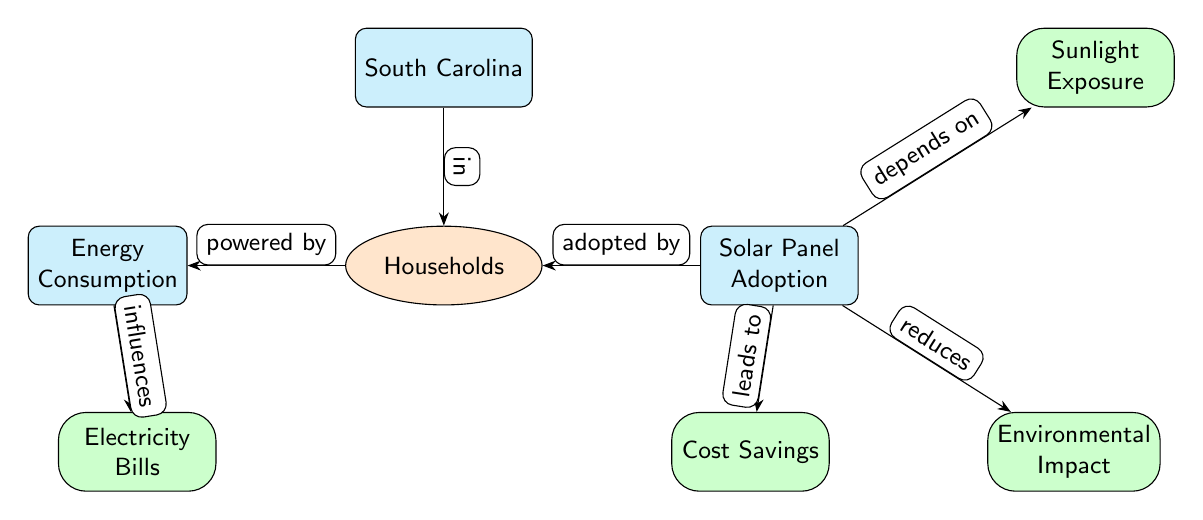What is the main topic of the diagram? The primary focus of the diagram is on the relationship between energy consumption and solar panel adoption within South Carolina households, indicated by the main nodes.
Answer: Energy Consumption and Solar Panel Adoption How many main nodes are in the diagram? Counting the nodes classified under the main category, there are three main nodes: South Carolina, Energy Consumption, and Solar Panel Adoption.
Answer: 3 Which node is influenced by energy consumption? The Electricity Bills node is directly indicated to be influenced by the Energy Consumption node, as shown by the edge labeled "influences."
Answer: Electricity Bills What does solar panel adoption lead to? According to the diagram, Solar Panel Adoption leads to Cost Savings, showing its impact on financial aspects for households.
Answer: Cost Savings How is solar panel adoption related to sunlight exposure? The diagram specifies that Solar Panel Adoption "depends on" Sunlight Exposure, indicating a necessary relationship between the two.
Answer: Depends on What are the three impacts of solar panel adoption? The diagram illustrates three consequences of solar panel adoption: Cost Savings, Environmental Impact, and the reliance on Sunlight Exposure.
Answer: Cost Savings, Environmental Impact Which node is located to the right of households? The Solar Panel Adoption node is positioned to the right of the Households node, as shown in the diagram layout.
Answer: Solar Panel Adoption What is directly powered by households? The diagram clearly indicates that Energy Consumption is powered by the Households node.
Answer: Energy Consumption What type of diagram is this? This is a Natural Science Diagram, specifically designed to visualize the relationships and influences among various factors related to energy consumption and solar panel adoption.
Answer: Natural Science Diagram 